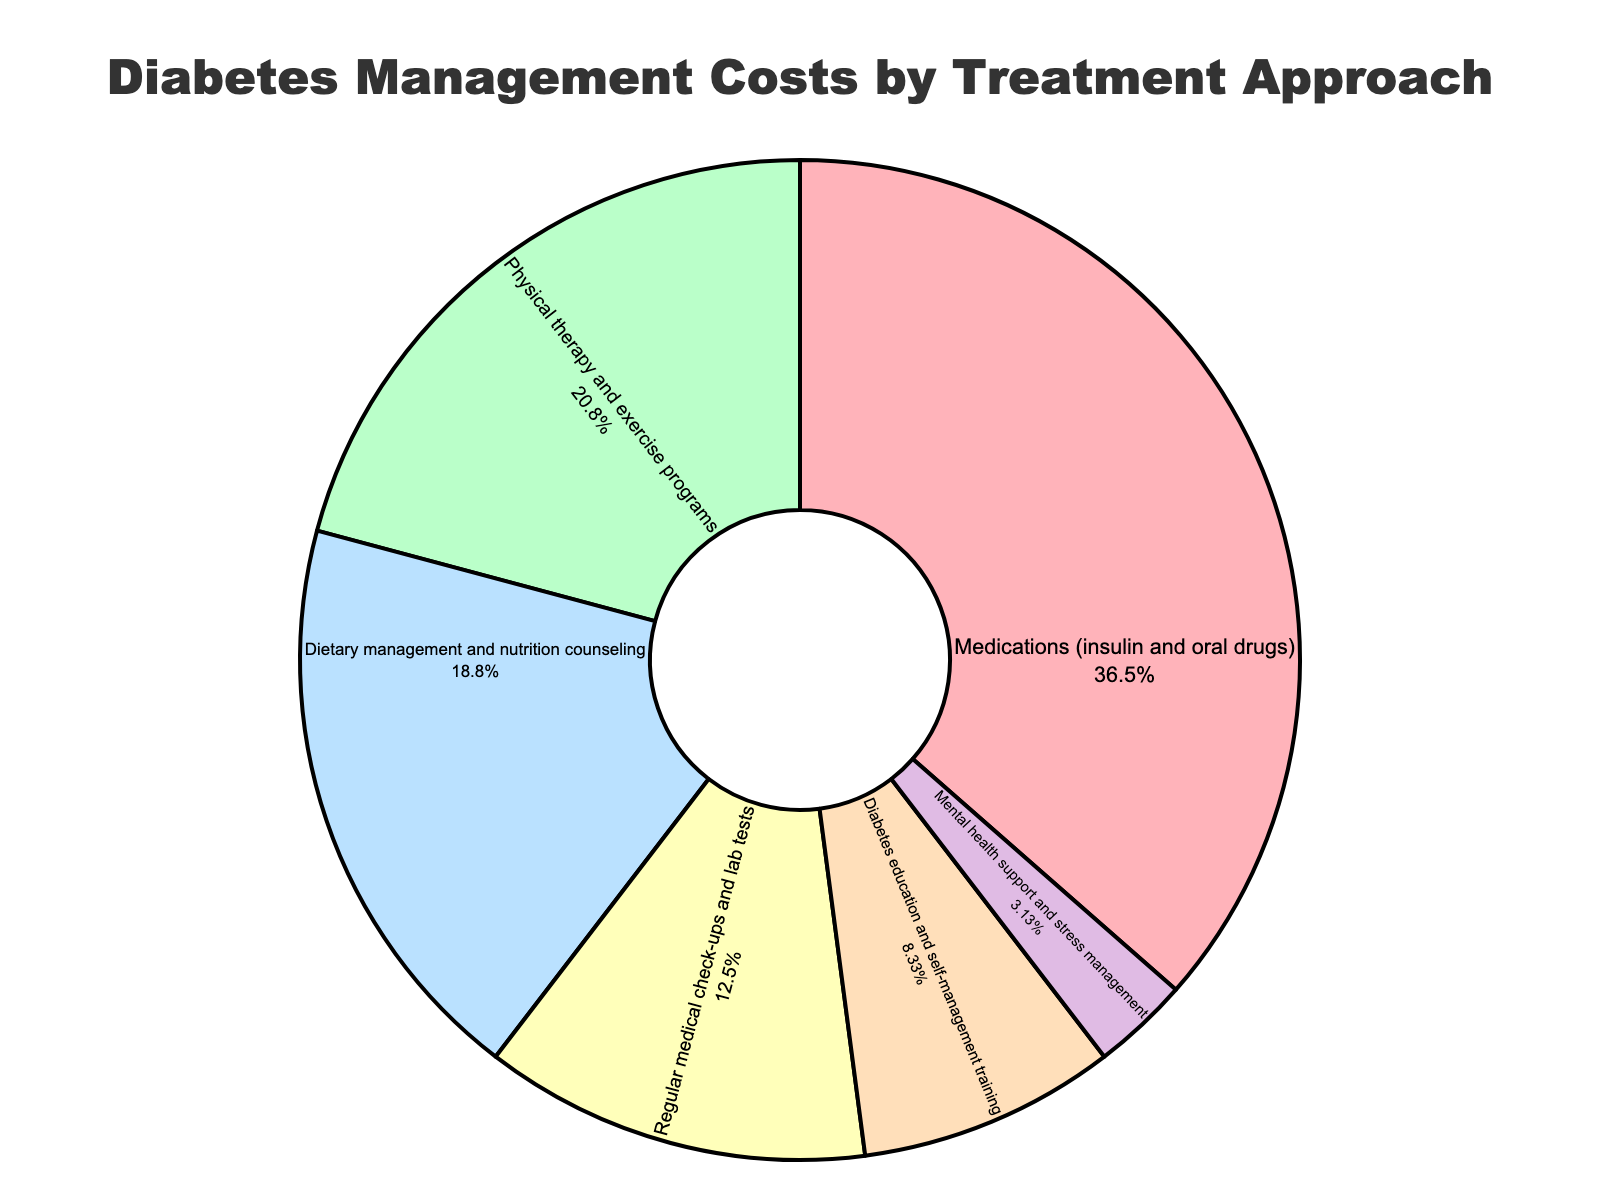What percentage of diabetes management costs is attributed to dietary management and nutrition counseling? According to the pie chart, dietary management and nutrition counseling account for 18% of diabetes management costs.
Answer: 18% How do the costs of regular medical check-ups and lab tests compare to mental health support and stress management costs? From the figure, regular medical check-ups and lab tests account for 12% of the costs, whereas mental health support and stress management account for 3%. Therefore, regular medical check-ups and lab tests cost 9% more than mental health support and stress management.
Answer: 9% more Which treatment approach accounts for the largest percentage of diabetes management costs? Looking at the pie chart, medications (insulin and oral drugs) account for the largest percentage of diabetes management costs at 35%.
Answer: Medications (insulin and oral drugs) What is the combined percentage of costs attributed to physical therapy and exercise programs and diabetes education and self-management training? According to the pie chart, physical therapy and exercise programs are 20%, and diabetes education and self-management training are 8%. Combined, they account for 20% + 8% = 28%.
Answer: 28% If dietary management and nutrition counseling and regular medical check-ups and lab tests together account for 30% of the costs, what percentage is left for other approaches? Dietary management and nutrition counseling (18%) and regular medical check-ups and lab tests (12%) together account for 30%. Subtracting this from 100% (total costs) leaves us with 100% - 30% = 70% for other approaches.
Answer: 70% Which treatment approaches together constitute more than half of the diabetes management costs? Medications (35%) and physical therapy and exercise programs (20%) together constitute 35% + 20% = 55%, which is more than half of the total costs.
Answer: Medications and physical therapy and exercise programs What is the difference in percentage between the treatment approach with the smallest cost and the one with the largest cost? Medications (insulin and oral drugs) account for 35%, which is the largest, and mental health support and stress management account for 3%, which is the smallest. The difference is 35% - 3% = 32%.
Answer: 32% 